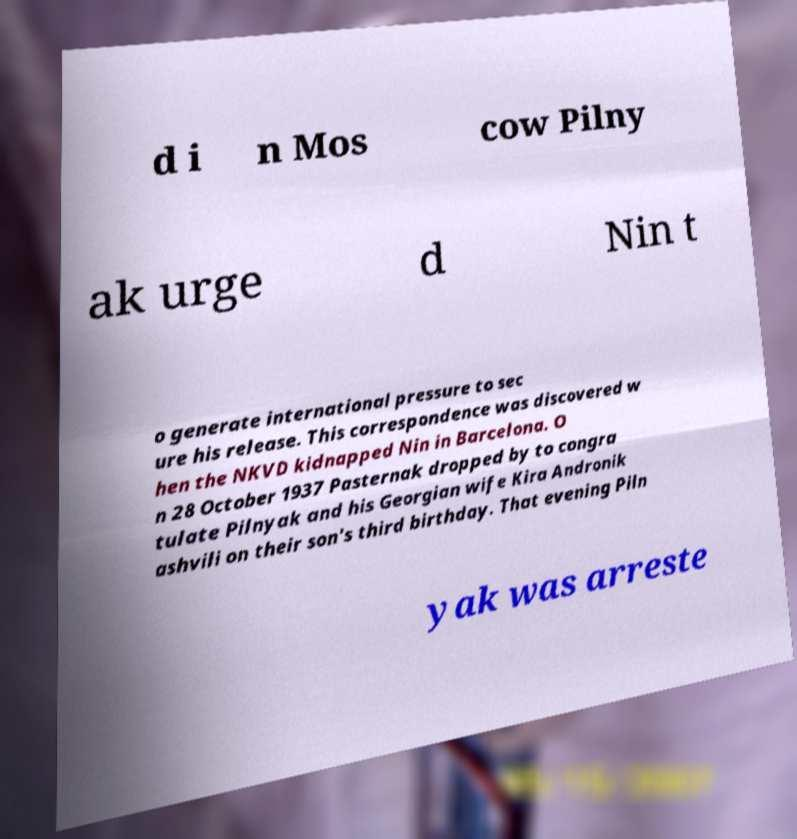There's text embedded in this image that I need extracted. Can you transcribe it verbatim? d i n Mos cow Pilny ak urge d Nin t o generate international pressure to sec ure his release. This correspondence was discovered w hen the NKVD kidnapped Nin in Barcelona. O n 28 October 1937 Pasternak dropped by to congra tulate Pilnyak and his Georgian wife Kira Andronik ashvili on their son's third birthday. That evening Piln yak was arreste 